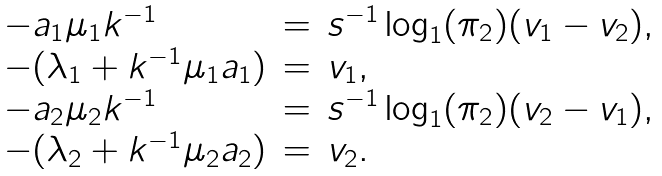Convert formula to latex. <formula><loc_0><loc_0><loc_500><loc_500>\begin{array} { l c l } - a _ { 1 } \mu _ { 1 } k ^ { - 1 } & = & s ^ { - 1 } \log _ { 1 } ( \pi _ { 2 } ) ( v _ { 1 } - v _ { 2 } ) , \\ - ( \lambda _ { 1 } + k ^ { - 1 } \mu _ { 1 } a _ { 1 } ) & = & v _ { 1 } , \\ - a _ { 2 } \mu _ { 2 } k ^ { - 1 } & = & s ^ { - 1 } \log _ { 1 } ( \pi _ { 2 } ) ( v _ { 2 } - v _ { 1 } ) , \\ - ( \lambda _ { 2 } + k ^ { - 1 } \mu _ { 2 } a _ { 2 } ) & = & v _ { 2 } . \end{array}</formula> 